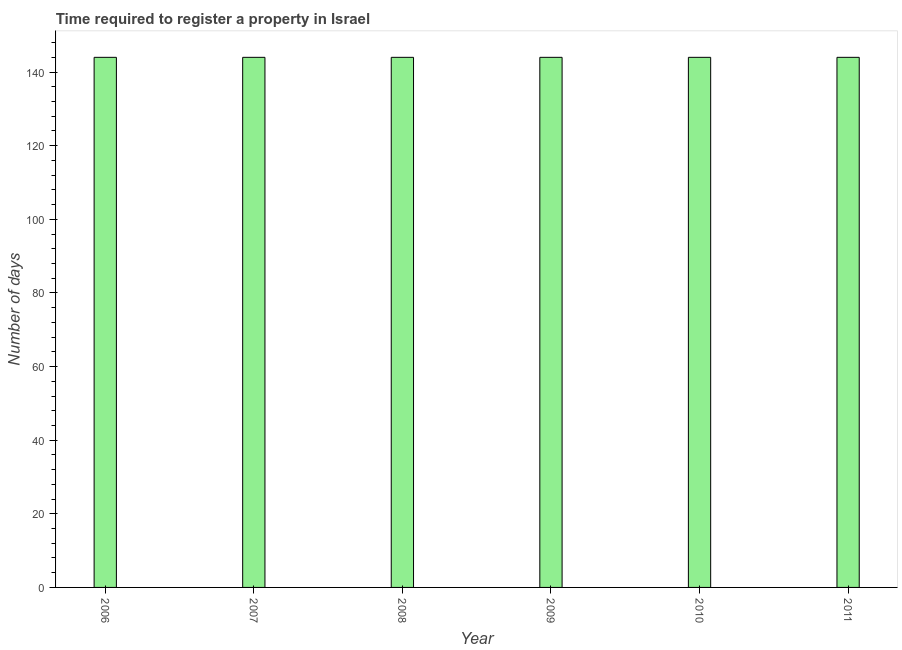Does the graph contain any zero values?
Give a very brief answer. No. What is the title of the graph?
Keep it short and to the point. Time required to register a property in Israel. What is the label or title of the X-axis?
Your answer should be very brief. Year. What is the label or title of the Y-axis?
Offer a terse response. Number of days. What is the number of days required to register property in 2011?
Give a very brief answer. 144. Across all years, what is the maximum number of days required to register property?
Keep it short and to the point. 144. Across all years, what is the minimum number of days required to register property?
Your answer should be compact. 144. In which year was the number of days required to register property minimum?
Your answer should be compact. 2006. What is the sum of the number of days required to register property?
Provide a succinct answer. 864. What is the average number of days required to register property per year?
Make the answer very short. 144. What is the median number of days required to register property?
Give a very brief answer. 144. In how many years, is the number of days required to register property greater than 60 days?
Make the answer very short. 6. What is the ratio of the number of days required to register property in 2006 to that in 2009?
Your answer should be compact. 1. Is the difference between the number of days required to register property in 2006 and 2007 greater than the difference between any two years?
Give a very brief answer. Yes. What is the difference between the highest and the second highest number of days required to register property?
Ensure brevity in your answer.  0. What is the difference between the highest and the lowest number of days required to register property?
Provide a succinct answer. 0. Are all the bars in the graph horizontal?
Your response must be concise. No. Are the values on the major ticks of Y-axis written in scientific E-notation?
Provide a short and direct response. No. What is the Number of days in 2006?
Your answer should be compact. 144. What is the Number of days in 2007?
Your answer should be very brief. 144. What is the Number of days of 2008?
Your response must be concise. 144. What is the Number of days of 2009?
Offer a very short reply. 144. What is the Number of days in 2010?
Provide a succinct answer. 144. What is the Number of days in 2011?
Your answer should be compact. 144. What is the difference between the Number of days in 2006 and 2008?
Provide a short and direct response. 0. What is the difference between the Number of days in 2006 and 2009?
Your answer should be very brief. 0. What is the difference between the Number of days in 2007 and 2008?
Provide a succinct answer. 0. What is the difference between the Number of days in 2007 and 2010?
Provide a short and direct response. 0. What is the difference between the Number of days in 2007 and 2011?
Ensure brevity in your answer.  0. What is the difference between the Number of days in 2008 and 2010?
Make the answer very short. 0. What is the difference between the Number of days in 2008 and 2011?
Provide a succinct answer. 0. What is the difference between the Number of days in 2009 and 2010?
Make the answer very short. 0. What is the difference between the Number of days in 2009 and 2011?
Your response must be concise. 0. What is the ratio of the Number of days in 2006 to that in 2008?
Make the answer very short. 1. What is the ratio of the Number of days in 2006 to that in 2009?
Offer a terse response. 1. What is the ratio of the Number of days in 2006 to that in 2010?
Make the answer very short. 1. What is the ratio of the Number of days in 2007 to that in 2011?
Keep it short and to the point. 1. What is the ratio of the Number of days in 2008 to that in 2011?
Provide a short and direct response. 1. What is the ratio of the Number of days in 2009 to that in 2010?
Provide a short and direct response. 1. What is the ratio of the Number of days in 2009 to that in 2011?
Make the answer very short. 1. 